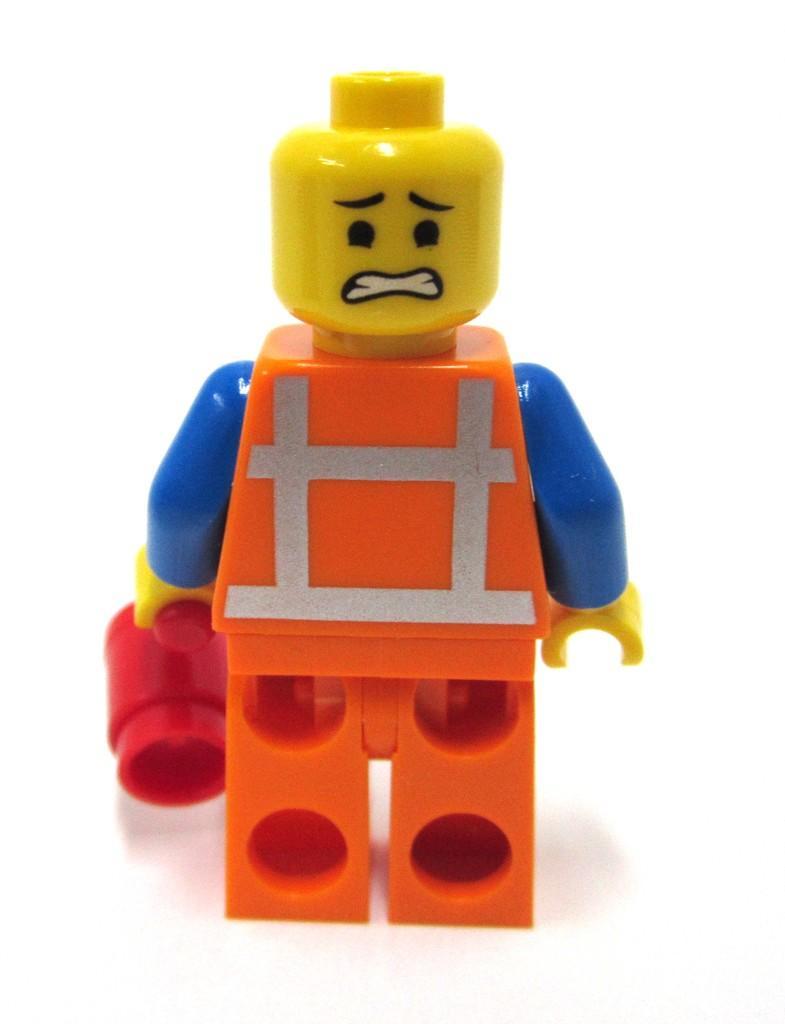In one or two sentences, can you explain what this image depicts? In the center of the image there is a toy. 